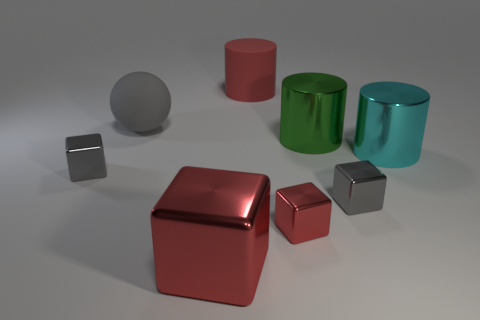Subtract all tiny red shiny blocks. How many blocks are left? 3 Add 1 green cylinders. How many objects exist? 9 Subtract all cyan cylinders. How many cylinders are left? 2 Subtract all yellow spheres. How many gray blocks are left? 2 Subtract 2 cubes. How many cubes are left? 2 Subtract all big things. Subtract all tiny green things. How many objects are left? 3 Add 6 big gray spheres. How many big gray spheres are left? 7 Add 7 big rubber cylinders. How many big rubber cylinders exist? 8 Subtract 0 green spheres. How many objects are left? 8 Subtract all balls. How many objects are left? 7 